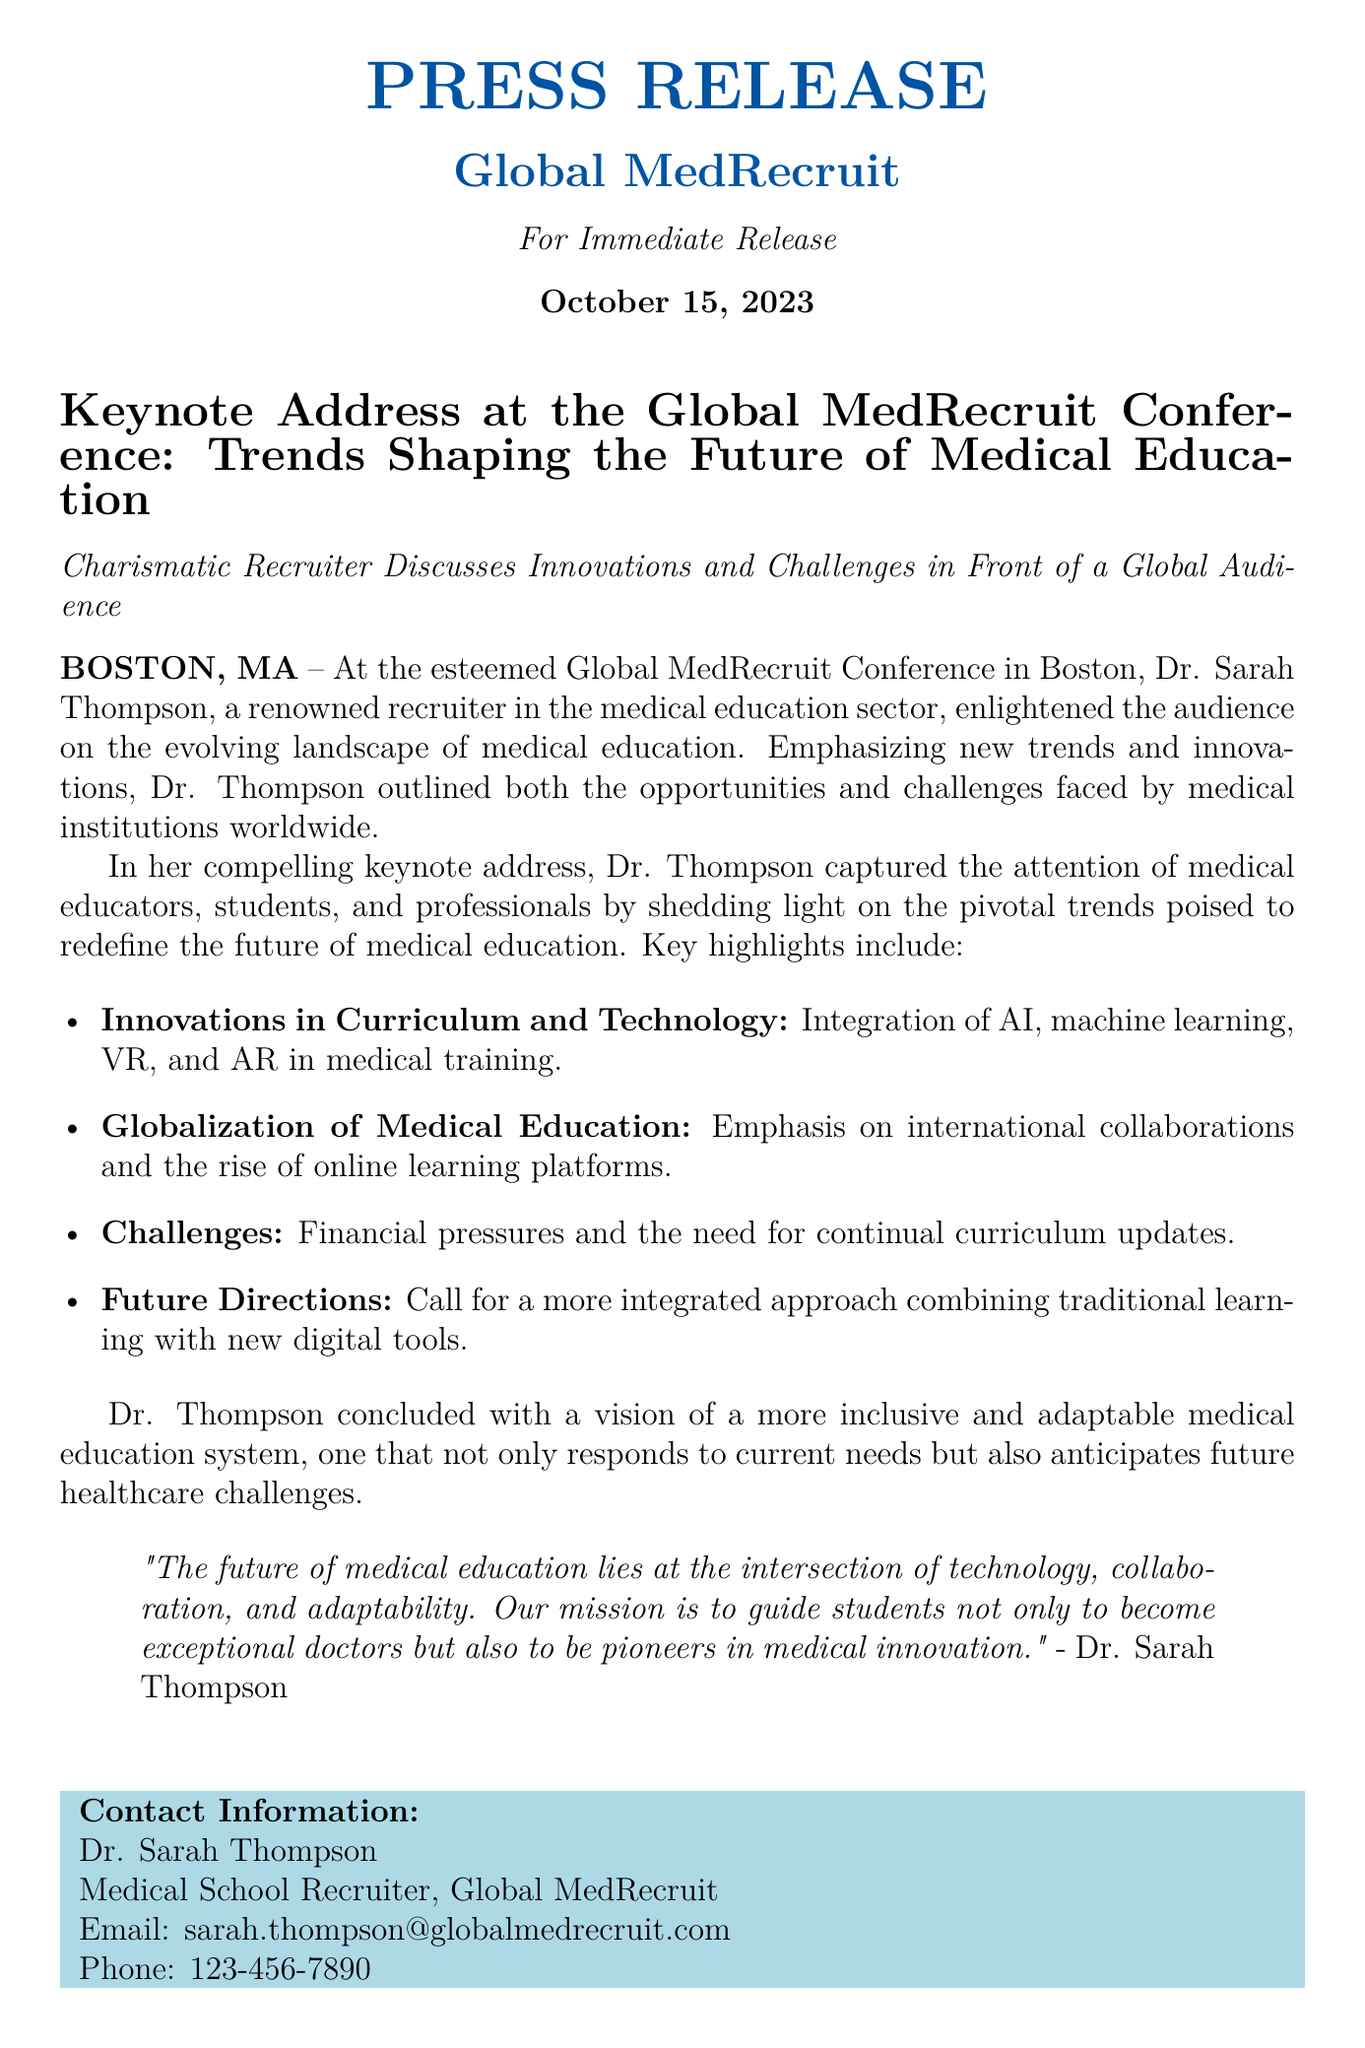What is the date of the press release? The date is explicitly stated at the beginning of the document.
Answer: October 15, 2023 Who delivered the keynote address? The document specifies Dr. Sarah Thompson as the presenter of the keynote address.
Answer: Dr. Sarah Thompson What is the location of the Global MedRecruit Conference? The city where the conference took place is mentioned in the document.
Answer: Boston, MA What is one key innovation discussed in the address? The document lists specific innovations that were emphasized during the keynote.
Answer: AI What challenge facing medical education is mentioned? The document outlines challenges, highlighting specific issues faced by medical institutions.
Answer: Financial pressures What is Dr. Sarah Thompson's role? The document gives a clear title related to her professional capacity.
Answer: Medical School Recruiter What is the overarching theme of the keynote address? The document summarizes the main focus of Dr. Thompson's speech in a succinct manner.
Answer: Trends shaping the future of medical education What is the main call to action from Dr. Thompson’s speech? The conclusion of the address provides a forward-looking perspective calling for specific changes.
Answer: More integrated approach 